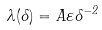Convert formula to latex. <formula><loc_0><loc_0><loc_500><loc_500>\lambda ( \delta ) = A \varepsilon \delta ^ { - 2 }</formula> 